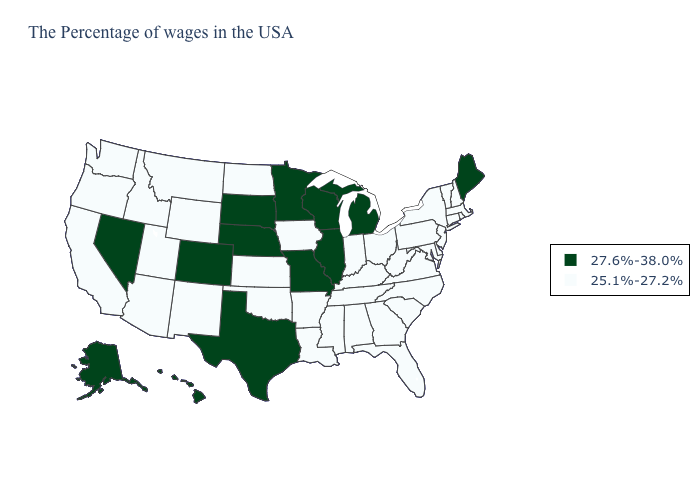What is the value of Hawaii?
Be succinct. 27.6%-38.0%. Among the states that border Louisiana , does Texas have the highest value?
Answer briefly. Yes. Name the states that have a value in the range 27.6%-38.0%?
Be succinct. Maine, Michigan, Wisconsin, Illinois, Missouri, Minnesota, Nebraska, Texas, South Dakota, Colorado, Nevada, Alaska, Hawaii. What is the highest value in states that border Iowa?
Keep it brief. 27.6%-38.0%. Does Wyoming have a lower value than Illinois?
Keep it brief. Yes. Among the states that border Minnesota , which have the lowest value?
Concise answer only. Iowa, North Dakota. Among the states that border Arkansas , which have the highest value?
Short answer required. Missouri, Texas. What is the lowest value in the MidWest?
Give a very brief answer. 25.1%-27.2%. What is the value of Arkansas?
Give a very brief answer. 25.1%-27.2%. Name the states that have a value in the range 27.6%-38.0%?
Give a very brief answer. Maine, Michigan, Wisconsin, Illinois, Missouri, Minnesota, Nebraska, Texas, South Dakota, Colorado, Nevada, Alaska, Hawaii. Among the states that border Maine , which have the lowest value?
Quick response, please. New Hampshire. What is the highest value in states that border Missouri?
Answer briefly. 27.6%-38.0%. What is the lowest value in the Northeast?
Keep it brief. 25.1%-27.2%. Name the states that have a value in the range 25.1%-27.2%?
Answer briefly. Massachusetts, Rhode Island, New Hampshire, Vermont, Connecticut, New York, New Jersey, Delaware, Maryland, Pennsylvania, Virginia, North Carolina, South Carolina, West Virginia, Ohio, Florida, Georgia, Kentucky, Indiana, Alabama, Tennessee, Mississippi, Louisiana, Arkansas, Iowa, Kansas, Oklahoma, North Dakota, Wyoming, New Mexico, Utah, Montana, Arizona, Idaho, California, Washington, Oregon. 